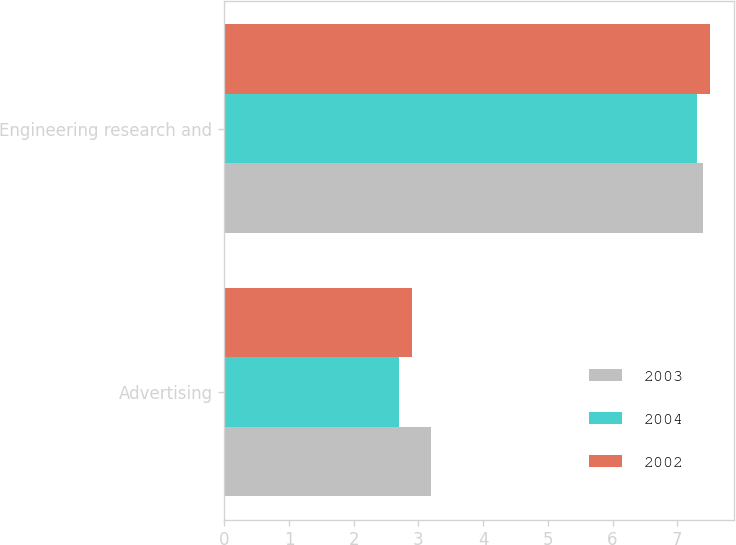Convert chart. <chart><loc_0><loc_0><loc_500><loc_500><stacked_bar_chart><ecel><fcel>Advertising<fcel>Engineering research and<nl><fcel>2003<fcel>3.2<fcel>7.4<nl><fcel>2004<fcel>2.7<fcel>7.3<nl><fcel>2002<fcel>2.9<fcel>7.5<nl></chart> 